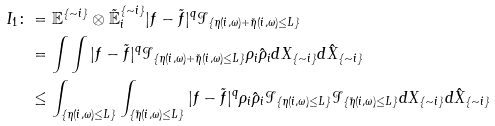<formula> <loc_0><loc_0><loc_500><loc_500>I _ { 1 } \colon & = \mathbb { E } ^ { \{ \sim i \} } \otimes \mathbb { \tilde { E } } ^ { \{ \sim i \} } _ { i } | f - \tilde { f } | ^ { q } \mathcal { I } _ { \{ \eta ( i , \omega ) + \tilde { \eta } ( i , \omega ) \leq L \} } \\ & = \int \int | f - \tilde { f } | ^ { q } \mathbb { \mathcal { I } } _ { \{ \eta ( i , \omega ) + \tilde { \eta } ( i , \omega ) \leq L \} } \rho _ { i } \hat { \rho } _ { i } d X _ { \{ \sim i \} } d \hat { X } _ { \{ \sim i \} } \\ & \leq \int _ { \{ \eta ( i , \omega ) \leq L \} } \int _ { \{ \tilde { \eta } ( i , \omega ) \leq L \} } | f - \tilde { f } | ^ { q } \rho _ { i } \hat { \rho } _ { i } \mathbb { \mathcal { I } } _ { \{ \eta ( i , \omega ) \leq L \} } \mathbb { \mathcal { I } } _ { \{ \tilde { \eta } ( i , \omega ) \leq L \} } d X _ { \{ \sim i \} } d \hat { X } _ { \{ \sim i \} }</formula> 